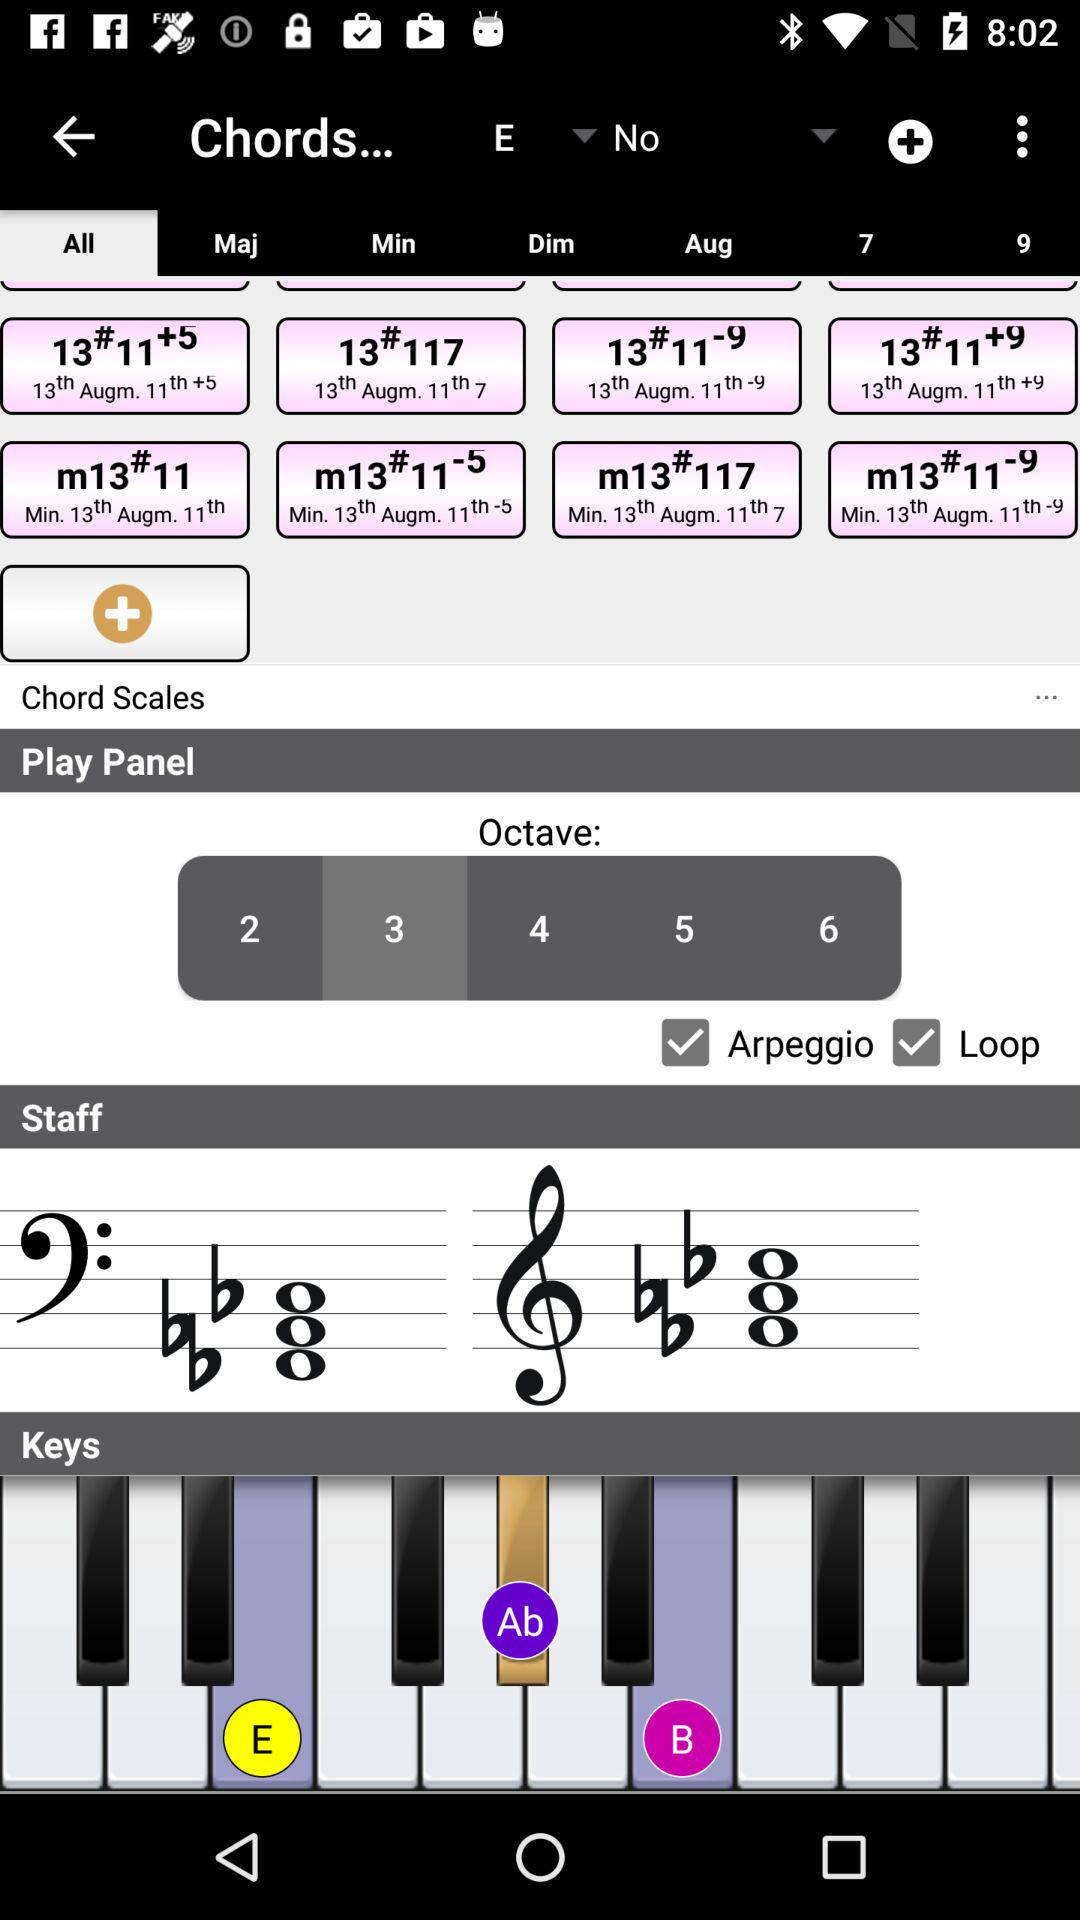What is the selected octave number? The selected octave number is 3. 